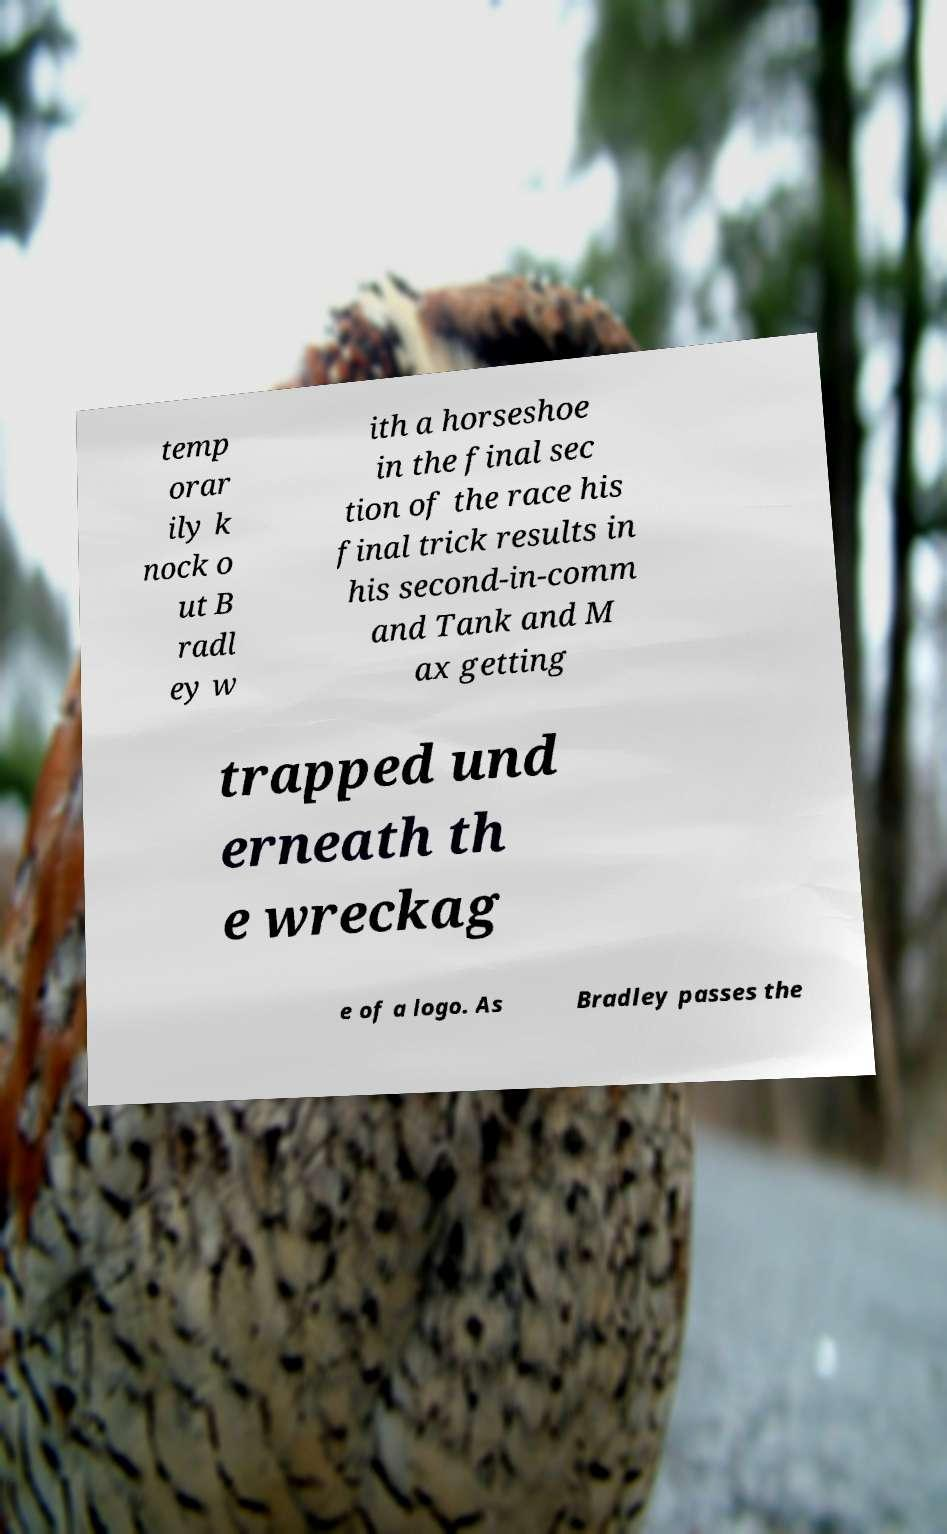Could you assist in decoding the text presented in this image and type it out clearly? temp orar ily k nock o ut B radl ey w ith a horseshoe in the final sec tion of the race his final trick results in his second-in-comm and Tank and M ax getting trapped und erneath th e wreckag e of a logo. As Bradley passes the 